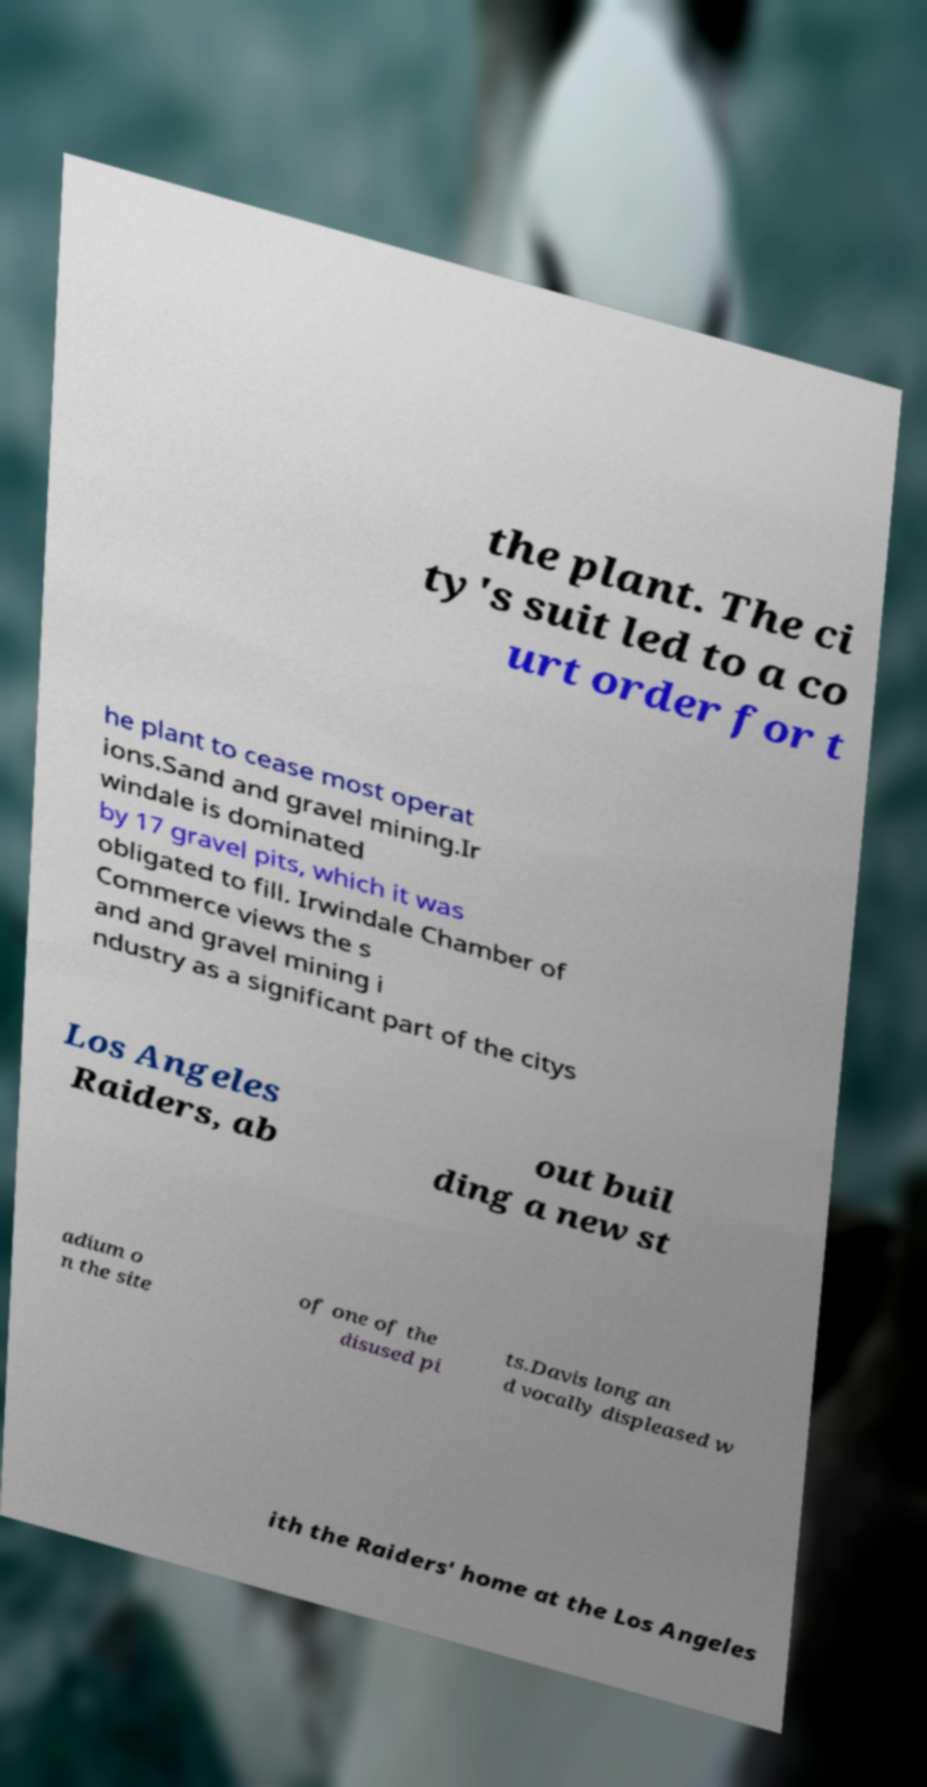Please read and relay the text visible in this image. What does it say? the plant. The ci ty's suit led to a co urt order for t he plant to cease most operat ions.Sand and gravel mining.Ir windale is dominated by 17 gravel pits, which it was obligated to fill. Irwindale Chamber of Commerce views the s and and gravel mining i ndustry as a significant part of the citys Los Angeles Raiders, ab out buil ding a new st adium o n the site of one of the disused pi ts.Davis long an d vocally displeased w ith the Raiders' home at the Los Angeles 